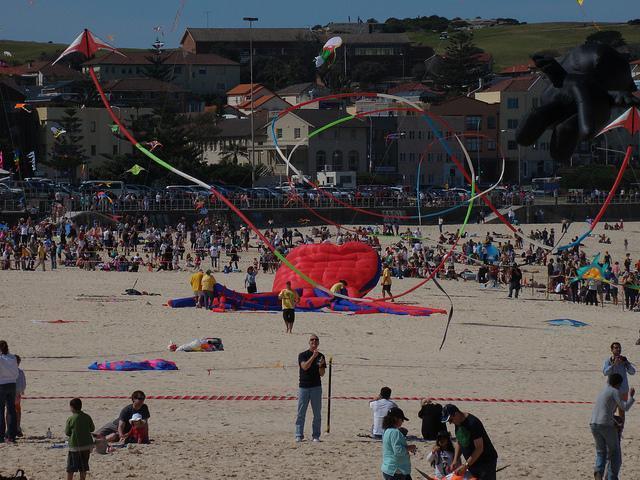How many people are there?
Give a very brief answer. 4. How many kites are visible?
Give a very brief answer. 3. How many umbrellas are visible?
Give a very brief answer. 0. 